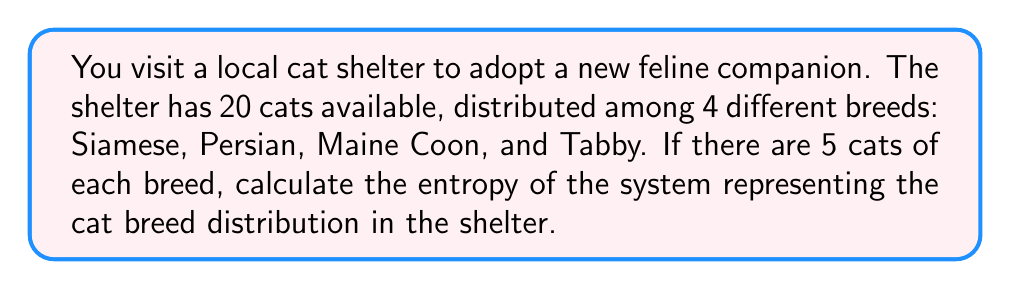Teach me how to tackle this problem. To calculate the entropy of this system, we'll use the Boltzmann entropy formula:

$$ S = k_B \ln W $$

Where:
$S$ is the entropy
$k_B$ is the Boltzmann constant
$W$ is the number of microstates (in this case, the number of ways to arrange the cats)

Step 1: Determine the number of microstates (W)
The number of ways to arrange 20 cats with 5 of each breed is given by the multinomial coefficient:

$$ W = \frac{20!}{5!5!5!5!} $$

Step 2: Calculate W
$$ W = \frac{20!}{(5!)^4} = 11,732,745,024 $$

Step 3: Apply the Boltzmann entropy formula
$$ S = k_B \ln(11,732,745,024) $$

Step 4: Simplify
$$ S = k_B \cdot 23.1863 $$

The final entropy is expressed in terms of $k_B$, as the Boltzmann constant's value depends on the units used for temperature and energy in the specific context.
Answer: $23.1863k_B$ 